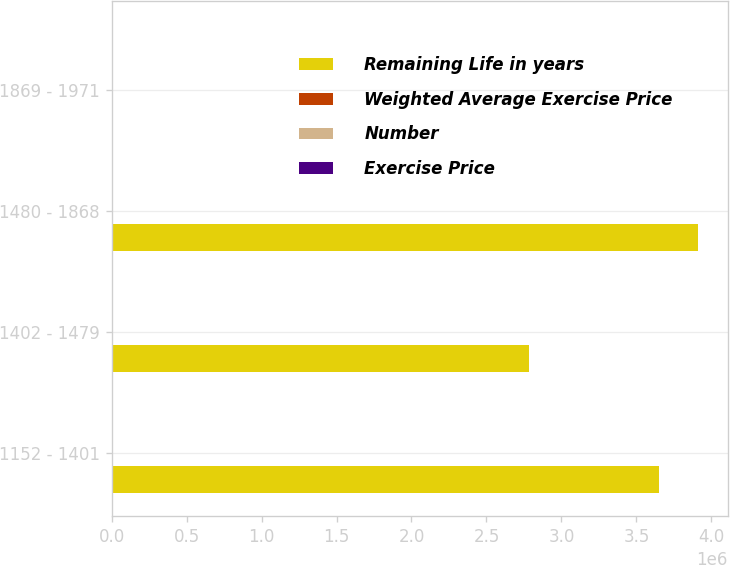Convert chart to OTSL. <chart><loc_0><loc_0><loc_500><loc_500><stacked_bar_chart><ecel><fcel>1152 - 1401<fcel>1402 - 1479<fcel>1480 - 1868<fcel>1869 - 1971<nl><fcel>Remaining Life in years<fcel>3.65078e+06<fcel>2.78231e+06<fcel>3.91304e+06<fcel>14.51<nl><fcel>Weighted Average Exercise Price<fcel>4.4<fcel>6.9<fcel>5.3<fcel>8.4<nl><fcel>Number<fcel>13.49<fcel>14.51<fcel>15.08<fcel>19.45<nl><fcel>Exercise Price<fcel>13.49<fcel>14.49<fcel>15.07<fcel>19.21<nl></chart> 